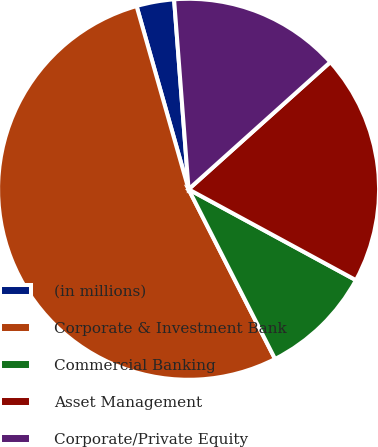Convert chart. <chart><loc_0><loc_0><loc_500><loc_500><pie_chart><fcel>(in millions)<fcel>Corporate & Investment Bank<fcel>Commercial Banking<fcel>Asset Management<fcel>Corporate/Private Equity<nl><fcel>3.19%<fcel>53.1%<fcel>9.58%<fcel>19.56%<fcel>14.57%<nl></chart> 